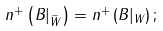Convert formula to latex. <formula><loc_0><loc_0><loc_500><loc_500>n ^ { + } \left ( B | _ { \widetilde { W } } \right ) = n ^ { + } \left ( B | _ { W } \right ) ;</formula> 